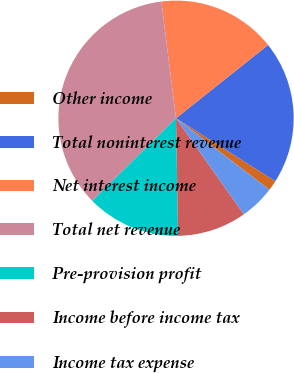Convert chart. <chart><loc_0><loc_0><loc_500><loc_500><pie_chart><fcel>Other income<fcel>Total noninterest revenue<fcel>Net interest income<fcel>Total net revenue<fcel>Pre-provision profit<fcel>Income before income tax<fcel>Income tax expense<nl><fcel>1.41%<fcel>19.69%<fcel>16.29%<fcel>35.4%<fcel>12.9%<fcel>9.5%<fcel>4.81%<nl></chart> 